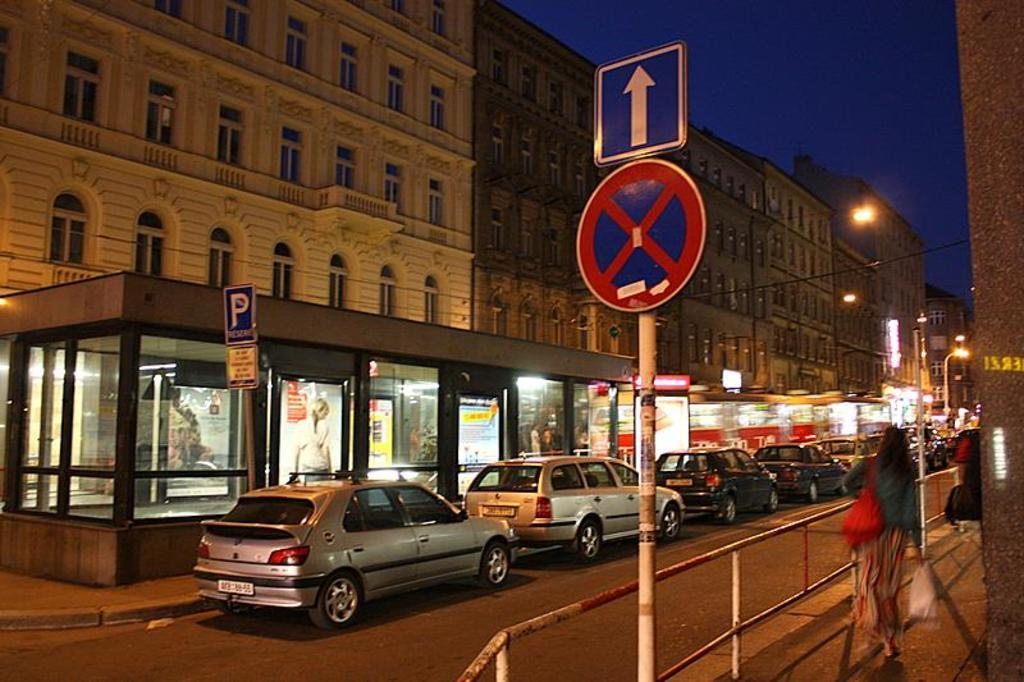What can be seen on the road in the image? There are cars on the road in the image. What is located on the right side of the image? There is a pole and a railing on the right side of the image. What is visible in the background of the image? There are buildings and the sky in the background of the image. What is the name of the person driving the car in the image? There is no specific person identified in the image, so we cannot determine the name of the person driving the car. Can you tell me how many quince trees are visible in the image? There are no quince trees present in the image. 